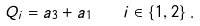<formula> <loc_0><loc_0><loc_500><loc_500>Q _ { i } = a _ { 3 } + a _ { 1 } \quad i \in \{ 1 , 2 \} \, .</formula> 